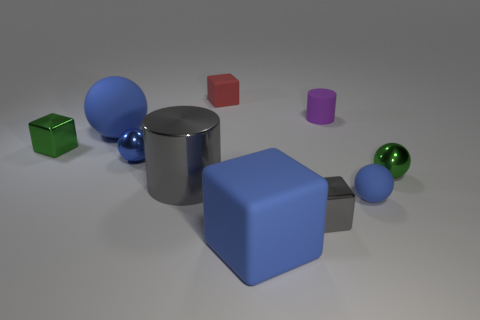There is a gray cylinder right of the large blue matte object that is behind the blue matte object right of the gray block; what is it made of?
Offer a very short reply. Metal. Is the number of small rubber things that are to the left of the big cylinder the same as the number of large purple metallic cylinders?
Ensure brevity in your answer.  Yes. Are the green object to the left of the purple matte cylinder and the big blue object that is behind the small blue matte sphere made of the same material?
Ensure brevity in your answer.  No. There is a tiny green thing that is on the left side of the big cube; does it have the same shape as the blue object that is to the right of the small purple cylinder?
Your response must be concise. No. Is the number of red objects right of the purple thing less than the number of purple blocks?
Make the answer very short. No. What number of small metal objects have the same color as the big shiny thing?
Provide a succinct answer. 1. There is a matte sphere that is left of the blue metal object; how big is it?
Provide a succinct answer. Large. What is the shape of the tiny green metallic object that is in front of the green object that is on the left side of the small green metallic object that is right of the blue block?
Provide a short and direct response. Sphere. There is a object that is behind the shiny cylinder and on the right side of the tiny purple object; what is its shape?
Give a very brief answer. Sphere. Are there any spheres of the same size as the blue metallic thing?
Provide a succinct answer. Yes. 